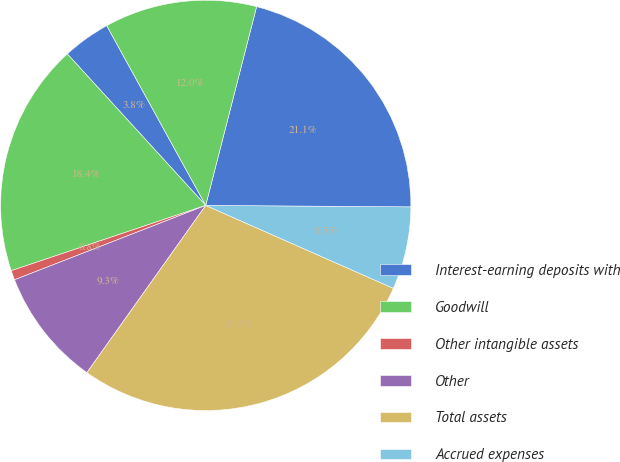Convert chart. <chart><loc_0><loc_0><loc_500><loc_500><pie_chart><fcel>Interest-earning deposits with<fcel>Goodwill<fcel>Other intangible assets<fcel>Other<fcel>Total assets<fcel>Accrued expenses<fcel>Total liabilities<fcel>Net assets<nl><fcel>3.77%<fcel>18.37%<fcel>0.75%<fcel>9.26%<fcel>28.2%<fcel>6.51%<fcel>21.12%<fcel>12.0%<nl></chart> 